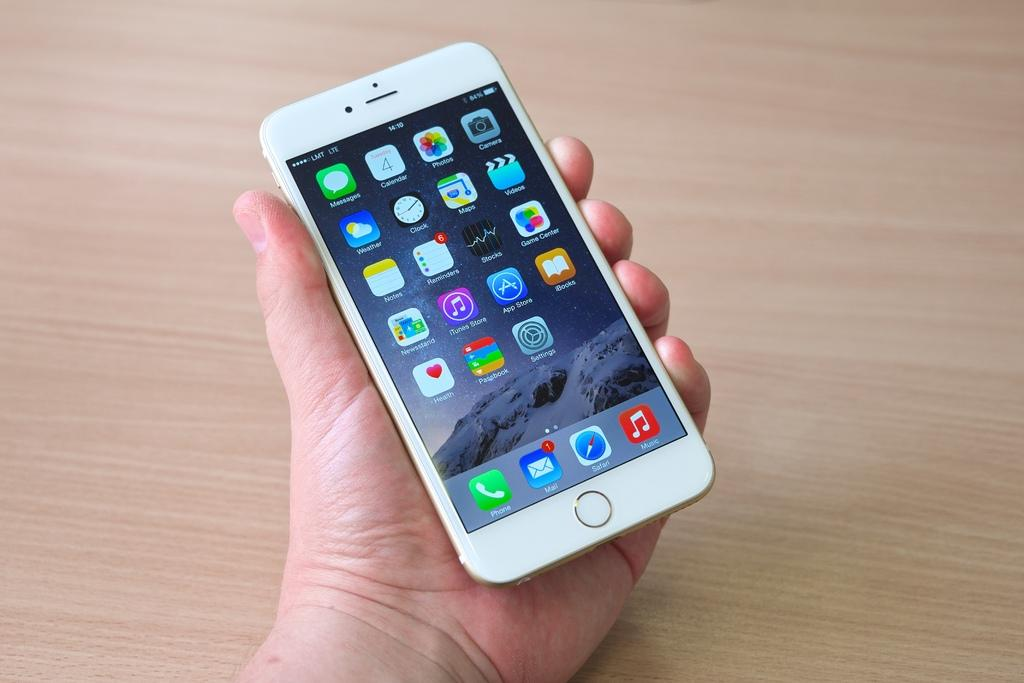<image>
Render a clear and concise summary of the photo. A person holding a white iphone and the mail icon has a message on it 